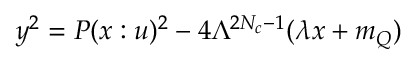<formula> <loc_0><loc_0><loc_500><loc_500>y ^ { 2 } = P ( x \colon u ) ^ { 2 } - 4 \Lambda ^ { 2 N _ { c } - 1 } ( \lambda x + m _ { Q } )</formula> 